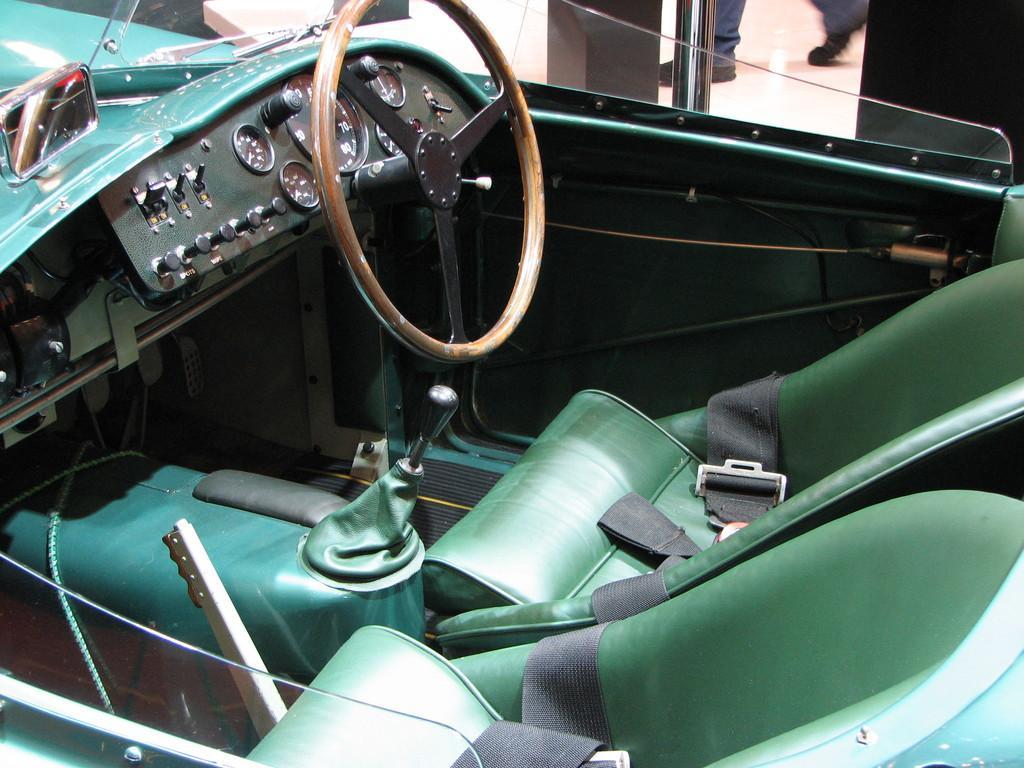How would you summarize this image in a sentence or two? In this image I can see the inner part of the vehicle. In the vehicle I can see the steering, speedometer, seats, gear rod and the glass. In the background I can see the person's legs. 